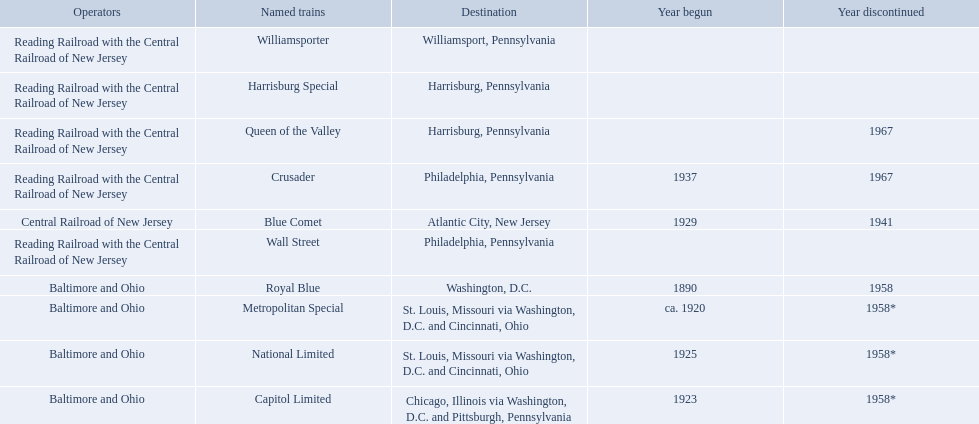Which operators are the reading railroad with the central railroad of new jersey? Reading Railroad with the Central Railroad of New Jersey, Reading Railroad with the Central Railroad of New Jersey, Reading Railroad with the Central Railroad of New Jersey, Reading Railroad with the Central Railroad of New Jersey, Reading Railroad with the Central Railroad of New Jersey. Which destinations are philadelphia, pennsylvania? Philadelphia, Pennsylvania, Philadelphia, Pennsylvania. What on began in 1937? 1937. What is the named train? Crusader. What were all of the destinations? Chicago, Illinois via Washington, D.C. and Pittsburgh, Pennsylvania, St. Louis, Missouri via Washington, D.C. and Cincinnati, Ohio, St. Louis, Missouri via Washington, D.C. and Cincinnati, Ohio, Washington, D.C., Atlantic City, New Jersey, Philadelphia, Pennsylvania, Harrisburg, Pennsylvania, Harrisburg, Pennsylvania, Philadelphia, Pennsylvania, Williamsport, Pennsylvania. And what were the names of the trains? Capitol Limited, Metropolitan Special, National Limited, Royal Blue, Blue Comet, Crusader, Harrisburg Special, Queen of the Valley, Wall Street, Williamsporter. Of those, and along with wall street, which train ran to philadelphia, pennsylvania? Crusader. 